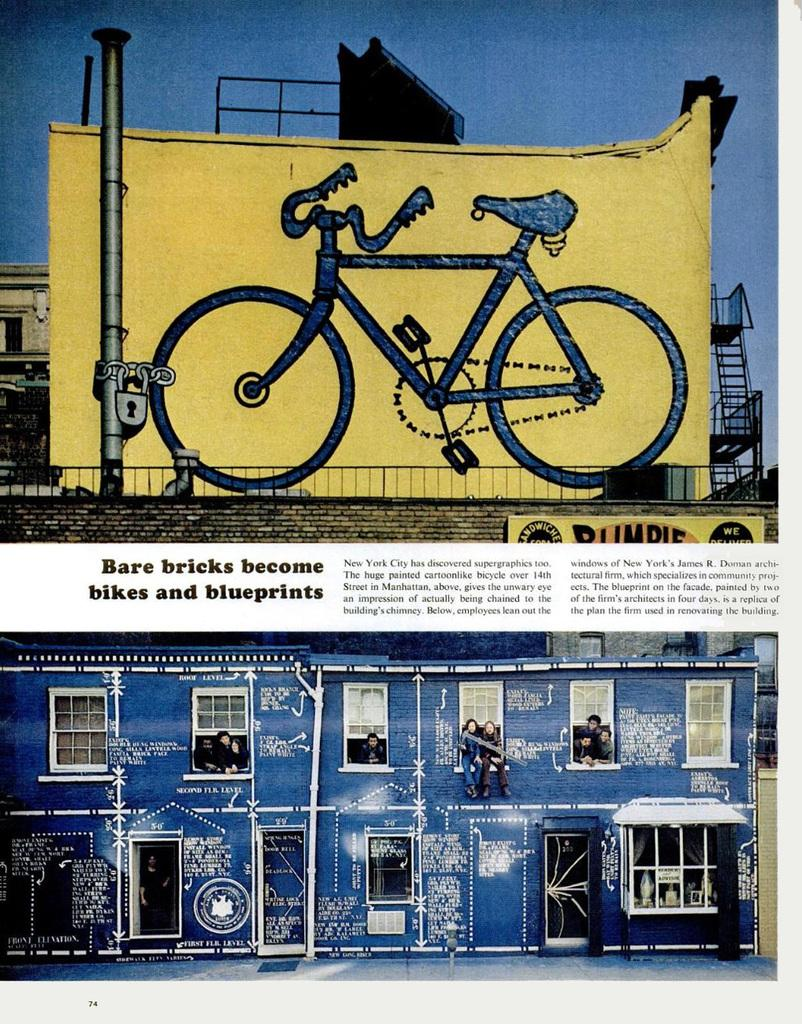What is the main subject of the poster in the image? The poster contains images of people, a bicycle, and buildings. Are there any objects or structures depicted on the poster? Yes, there is a pole depicted on the poster. Is there any text present on the poster? Yes, there is text on the poster. What type of trees can be seen in the image? There are no trees present in the image; it only features a poster with various images and text. How many bushes are visible in the image? There are no bushes visible in the image; it only features a poster with various images and text. 